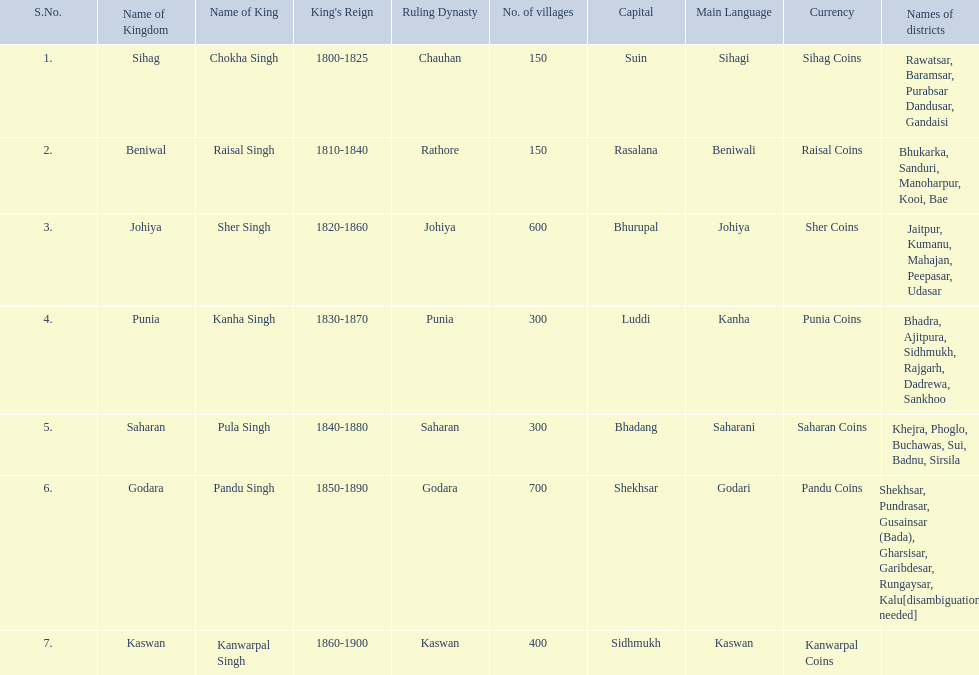What are the number of villages johiya has according to this chart? 600. 